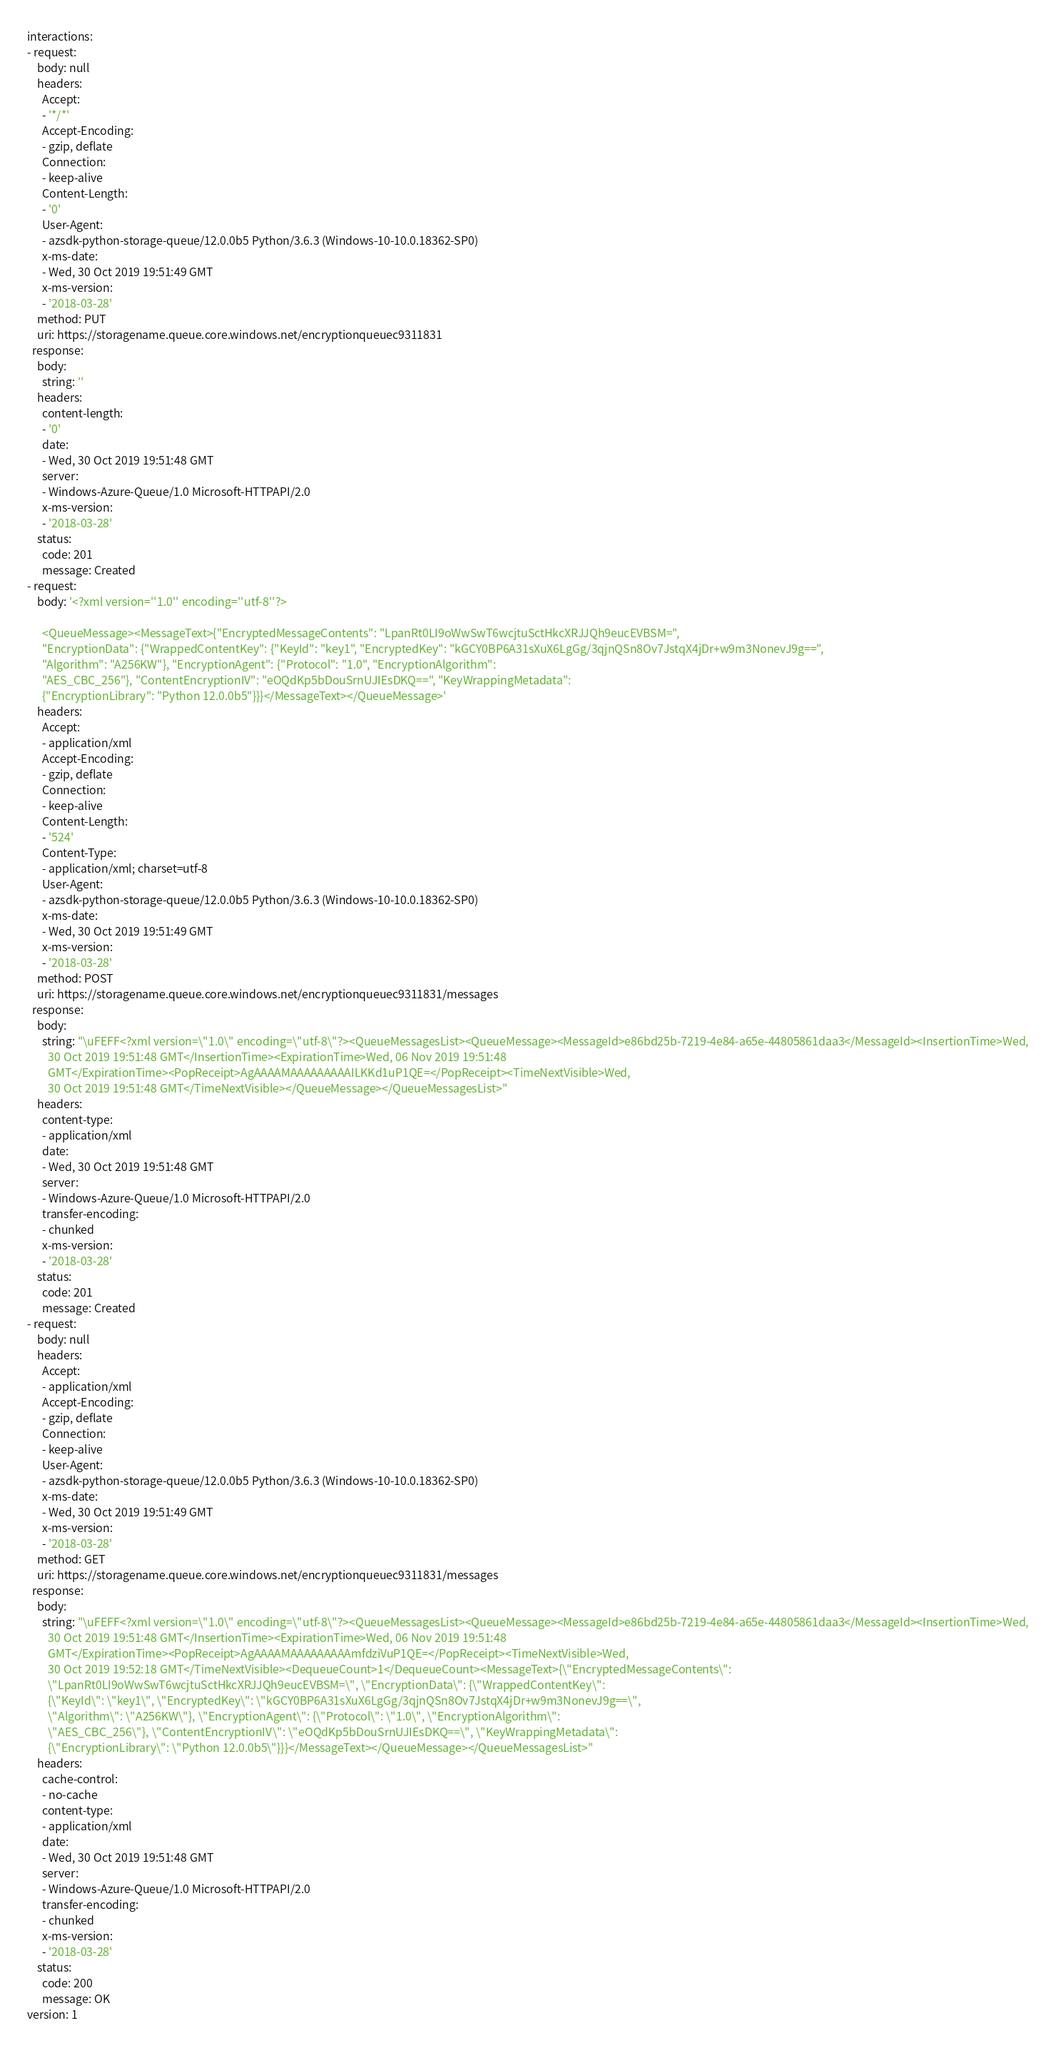<code> <loc_0><loc_0><loc_500><loc_500><_YAML_>interactions:
- request:
    body: null
    headers:
      Accept:
      - '*/*'
      Accept-Encoding:
      - gzip, deflate
      Connection:
      - keep-alive
      Content-Length:
      - '0'
      User-Agent:
      - azsdk-python-storage-queue/12.0.0b5 Python/3.6.3 (Windows-10-10.0.18362-SP0)
      x-ms-date:
      - Wed, 30 Oct 2019 19:51:49 GMT
      x-ms-version:
      - '2018-03-28'
    method: PUT
    uri: https://storagename.queue.core.windows.net/encryptionqueuec9311831
  response:
    body:
      string: ''
    headers:
      content-length:
      - '0'
      date:
      - Wed, 30 Oct 2019 19:51:48 GMT
      server:
      - Windows-Azure-Queue/1.0 Microsoft-HTTPAPI/2.0
      x-ms-version:
      - '2018-03-28'
    status:
      code: 201
      message: Created
- request:
    body: '<?xml version=''1.0'' encoding=''utf-8''?>

      <QueueMessage><MessageText>{"EncryptedMessageContents": "LpanRt0LI9oWwSwT6wcjtuSctHkcXRJJQh9eucEVBSM=",
      "EncryptionData": {"WrappedContentKey": {"KeyId": "key1", "EncryptedKey": "kGCY0BP6A31sXuX6LgGg/3qjnQSn8Ov7JstqX4jDr+w9m3NonevJ9g==",
      "Algorithm": "A256KW"}, "EncryptionAgent": {"Protocol": "1.0", "EncryptionAlgorithm":
      "AES_CBC_256"}, "ContentEncryptionIV": "eOQdKp5bDouSrnUJIEsDKQ==", "KeyWrappingMetadata":
      {"EncryptionLibrary": "Python 12.0.0b5"}}}</MessageText></QueueMessage>'
    headers:
      Accept:
      - application/xml
      Accept-Encoding:
      - gzip, deflate
      Connection:
      - keep-alive
      Content-Length:
      - '524'
      Content-Type:
      - application/xml; charset=utf-8
      User-Agent:
      - azsdk-python-storage-queue/12.0.0b5 Python/3.6.3 (Windows-10-10.0.18362-SP0)
      x-ms-date:
      - Wed, 30 Oct 2019 19:51:49 GMT
      x-ms-version:
      - '2018-03-28'
    method: POST
    uri: https://storagename.queue.core.windows.net/encryptionqueuec9311831/messages
  response:
    body:
      string: "\uFEFF<?xml version=\"1.0\" encoding=\"utf-8\"?><QueueMessagesList><QueueMessage><MessageId>e86bd25b-7219-4e84-a65e-44805861daa3</MessageId><InsertionTime>Wed,
        30 Oct 2019 19:51:48 GMT</InsertionTime><ExpirationTime>Wed, 06 Nov 2019 19:51:48
        GMT</ExpirationTime><PopReceipt>AgAAAAMAAAAAAAAAILKKd1uP1QE=</PopReceipt><TimeNextVisible>Wed,
        30 Oct 2019 19:51:48 GMT</TimeNextVisible></QueueMessage></QueueMessagesList>"
    headers:
      content-type:
      - application/xml
      date:
      - Wed, 30 Oct 2019 19:51:48 GMT
      server:
      - Windows-Azure-Queue/1.0 Microsoft-HTTPAPI/2.0
      transfer-encoding:
      - chunked
      x-ms-version:
      - '2018-03-28'
    status:
      code: 201
      message: Created
- request:
    body: null
    headers:
      Accept:
      - application/xml
      Accept-Encoding:
      - gzip, deflate
      Connection:
      - keep-alive
      User-Agent:
      - azsdk-python-storage-queue/12.0.0b5 Python/3.6.3 (Windows-10-10.0.18362-SP0)
      x-ms-date:
      - Wed, 30 Oct 2019 19:51:49 GMT
      x-ms-version:
      - '2018-03-28'
    method: GET
    uri: https://storagename.queue.core.windows.net/encryptionqueuec9311831/messages
  response:
    body:
      string: "\uFEFF<?xml version=\"1.0\" encoding=\"utf-8\"?><QueueMessagesList><QueueMessage><MessageId>e86bd25b-7219-4e84-a65e-44805861daa3</MessageId><InsertionTime>Wed,
        30 Oct 2019 19:51:48 GMT</InsertionTime><ExpirationTime>Wed, 06 Nov 2019 19:51:48
        GMT</ExpirationTime><PopReceipt>AgAAAAMAAAAAAAAAmfdziVuP1QE=</PopReceipt><TimeNextVisible>Wed,
        30 Oct 2019 19:52:18 GMT</TimeNextVisible><DequeueCount>1</DequeueCount><MessageText>{\"EncryptedMessageContents\":
        \"LpanRt0LI9oWwSwT6wcjtuSctHkcXRJJQh9eucEVBSM=\", \"EncryptionData\": {\"WrappedContentKey\":
        {\"KeyId\": \"key1\", \"EncryptedKey\": \"kGCY0BP6A31sXuX6LgGg/3qjnQSn8Ov7JstqX4jDr+w9m3NonevJ9g==\",
        \"Algorithm\": \"A256KW\"}, \"EncryptionAgent\": {\"Protocol\": \"1.0\", \"EncryptionAlgorithm\":
        \"AES_CBC_256\"}, \"ContentEncryptionIV\": \"eOQdKp5bDouSrnUJIEsDKQ==\", \"KeyWrappingMetadata\":
        {\"EncryptionLibrary\": \"Python 12.0.0b5\"}}}</MessageText></QueueMessage></QueueMessagesList>"
    headers:
      cache-control:
      - no-cache
      content-type:
      - application/xml
      date:
      - Wed, 30 Oct 2019 19:51:48 GMT
      server:
      - Windows-Azure-Queue/1.0 Microsoft-HTTPAPI/2.0
      transfer-encoding:
      - chunked
      x-ms-version:
      - '2018-03-28'
    status:
      code: 200
      message: OK
version: 1
</code> 